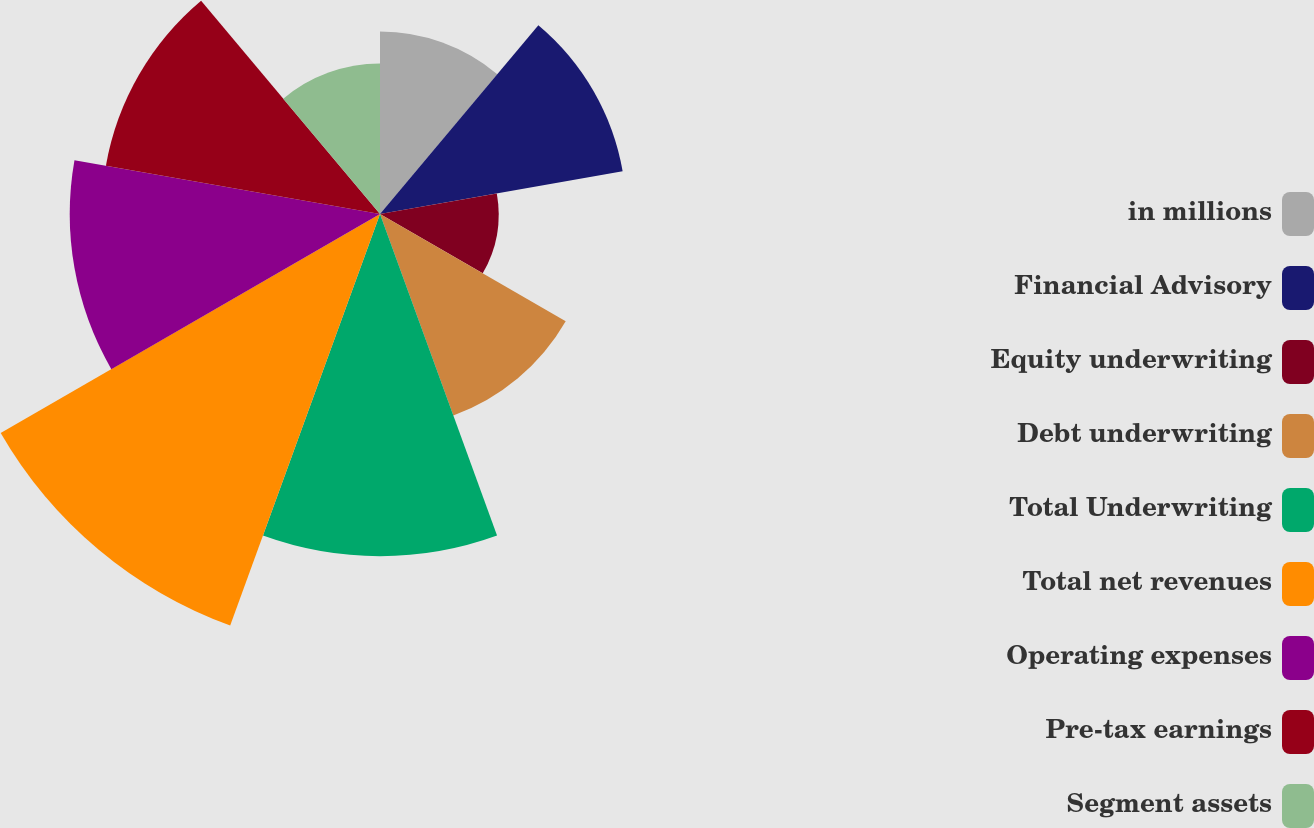Convert chart to OTSL. <chart><loc_0><loc_0><loc_500><loc_500><pie_chart><fcel>in millions<fcel>Financial Advisory<fcel>Equity underwriting<fcel>Debt underwriting<fcel>Total Underwriting<fcel>Total net revenues<fcel>Operating expenses<fcel>Pre-tax earnings<fcel>Segment assets<nl><fcel>8.0%<fcel>10.8%<fcel>5.2%<fcel>9.4%<fcel>15.0%<fcel>19.2%<fcel>13.6%<fcel>12.2%<fcel>6.6%<nl></chart> 